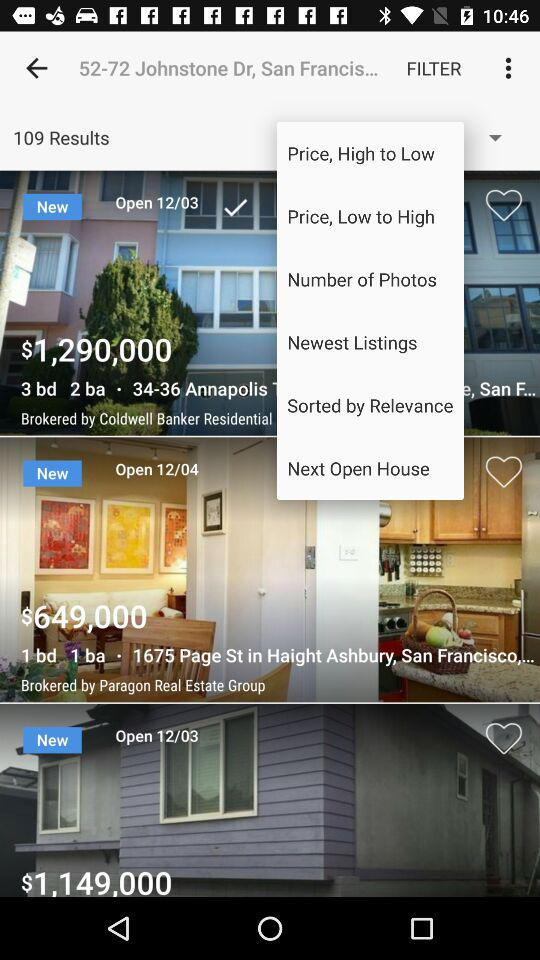How many results are there? There are 109 results. 